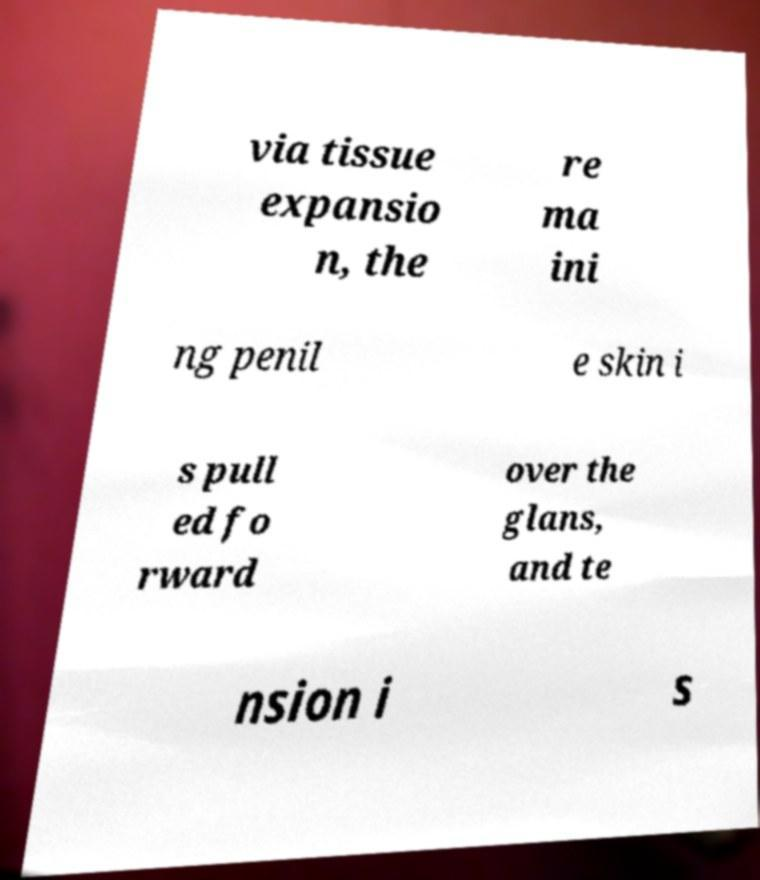Please read and relay the text visible in this image. What does it say? via tissue expansio n, the re ma ini ng penil e skin i s pull ed fo rward over the glans, and te nsion i s 